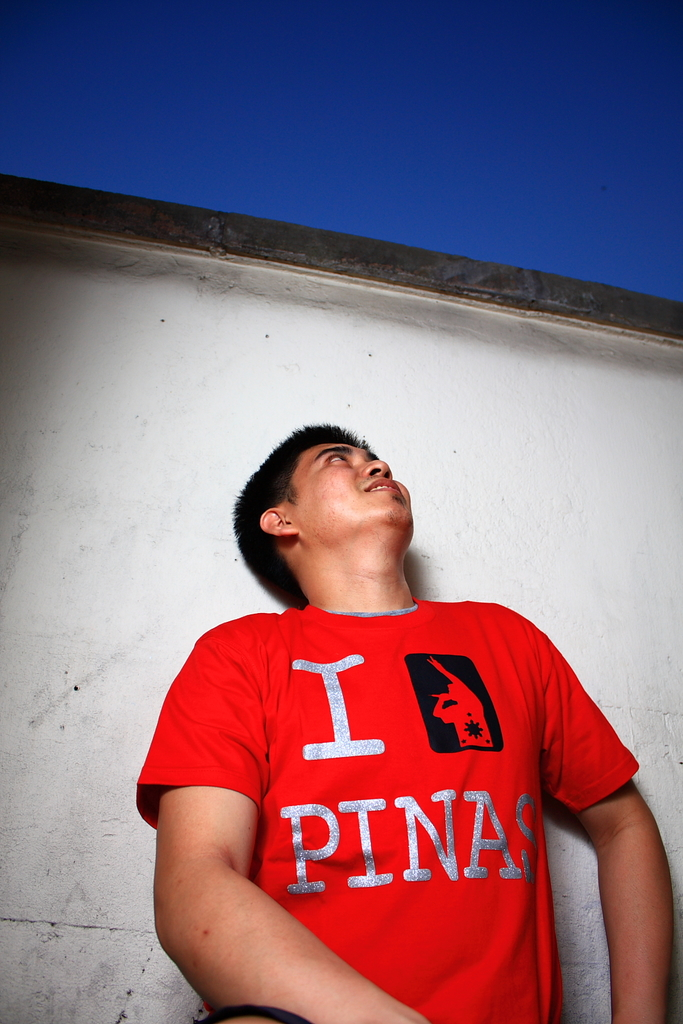Provide a one-sentence caption for the provided image. A young man gazes upwards thoughtfully, wearing a bright red shirt emblazoned with 'I Love Pinas' against a minimalistic white wall background, emphasizing his casual yet poignant demeanor. 